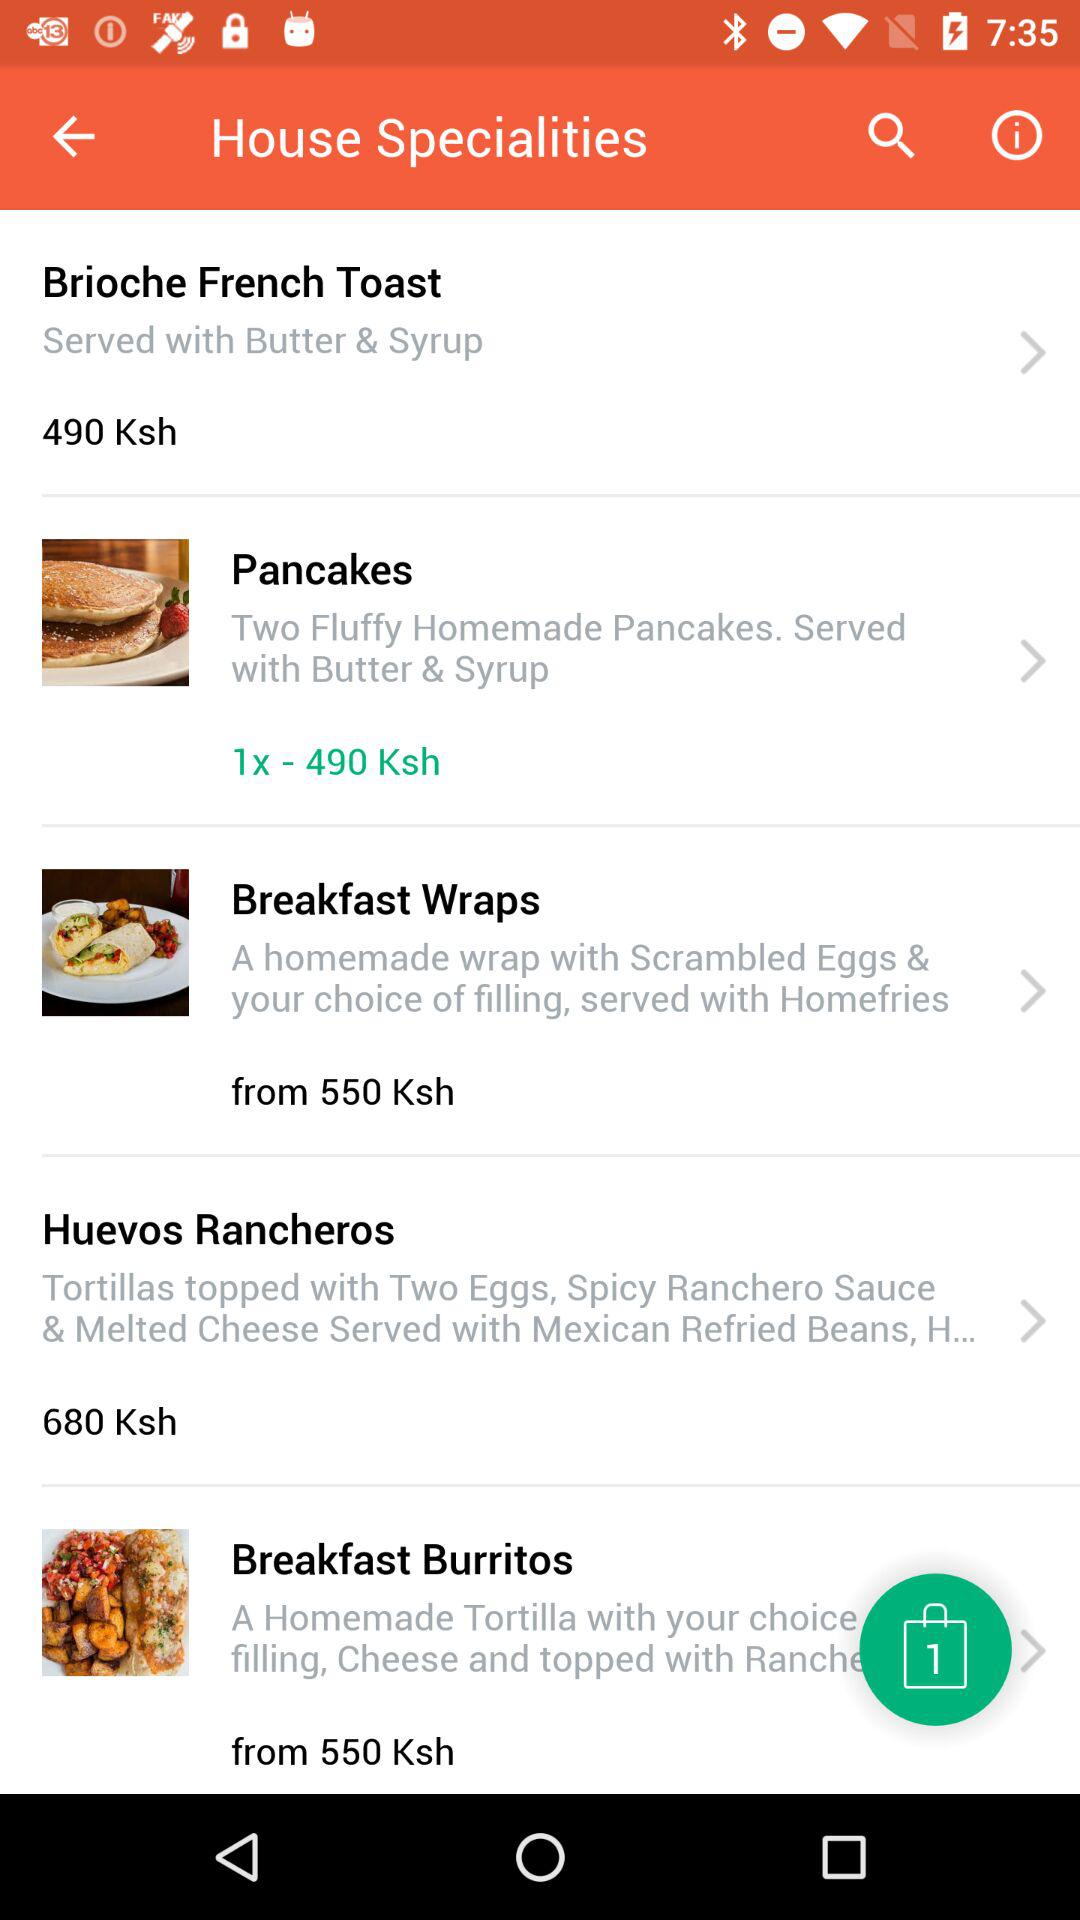What is the starting price of the breakfast wraps in ksh? The starting price of the breakfast wraps is 550 ksh. 